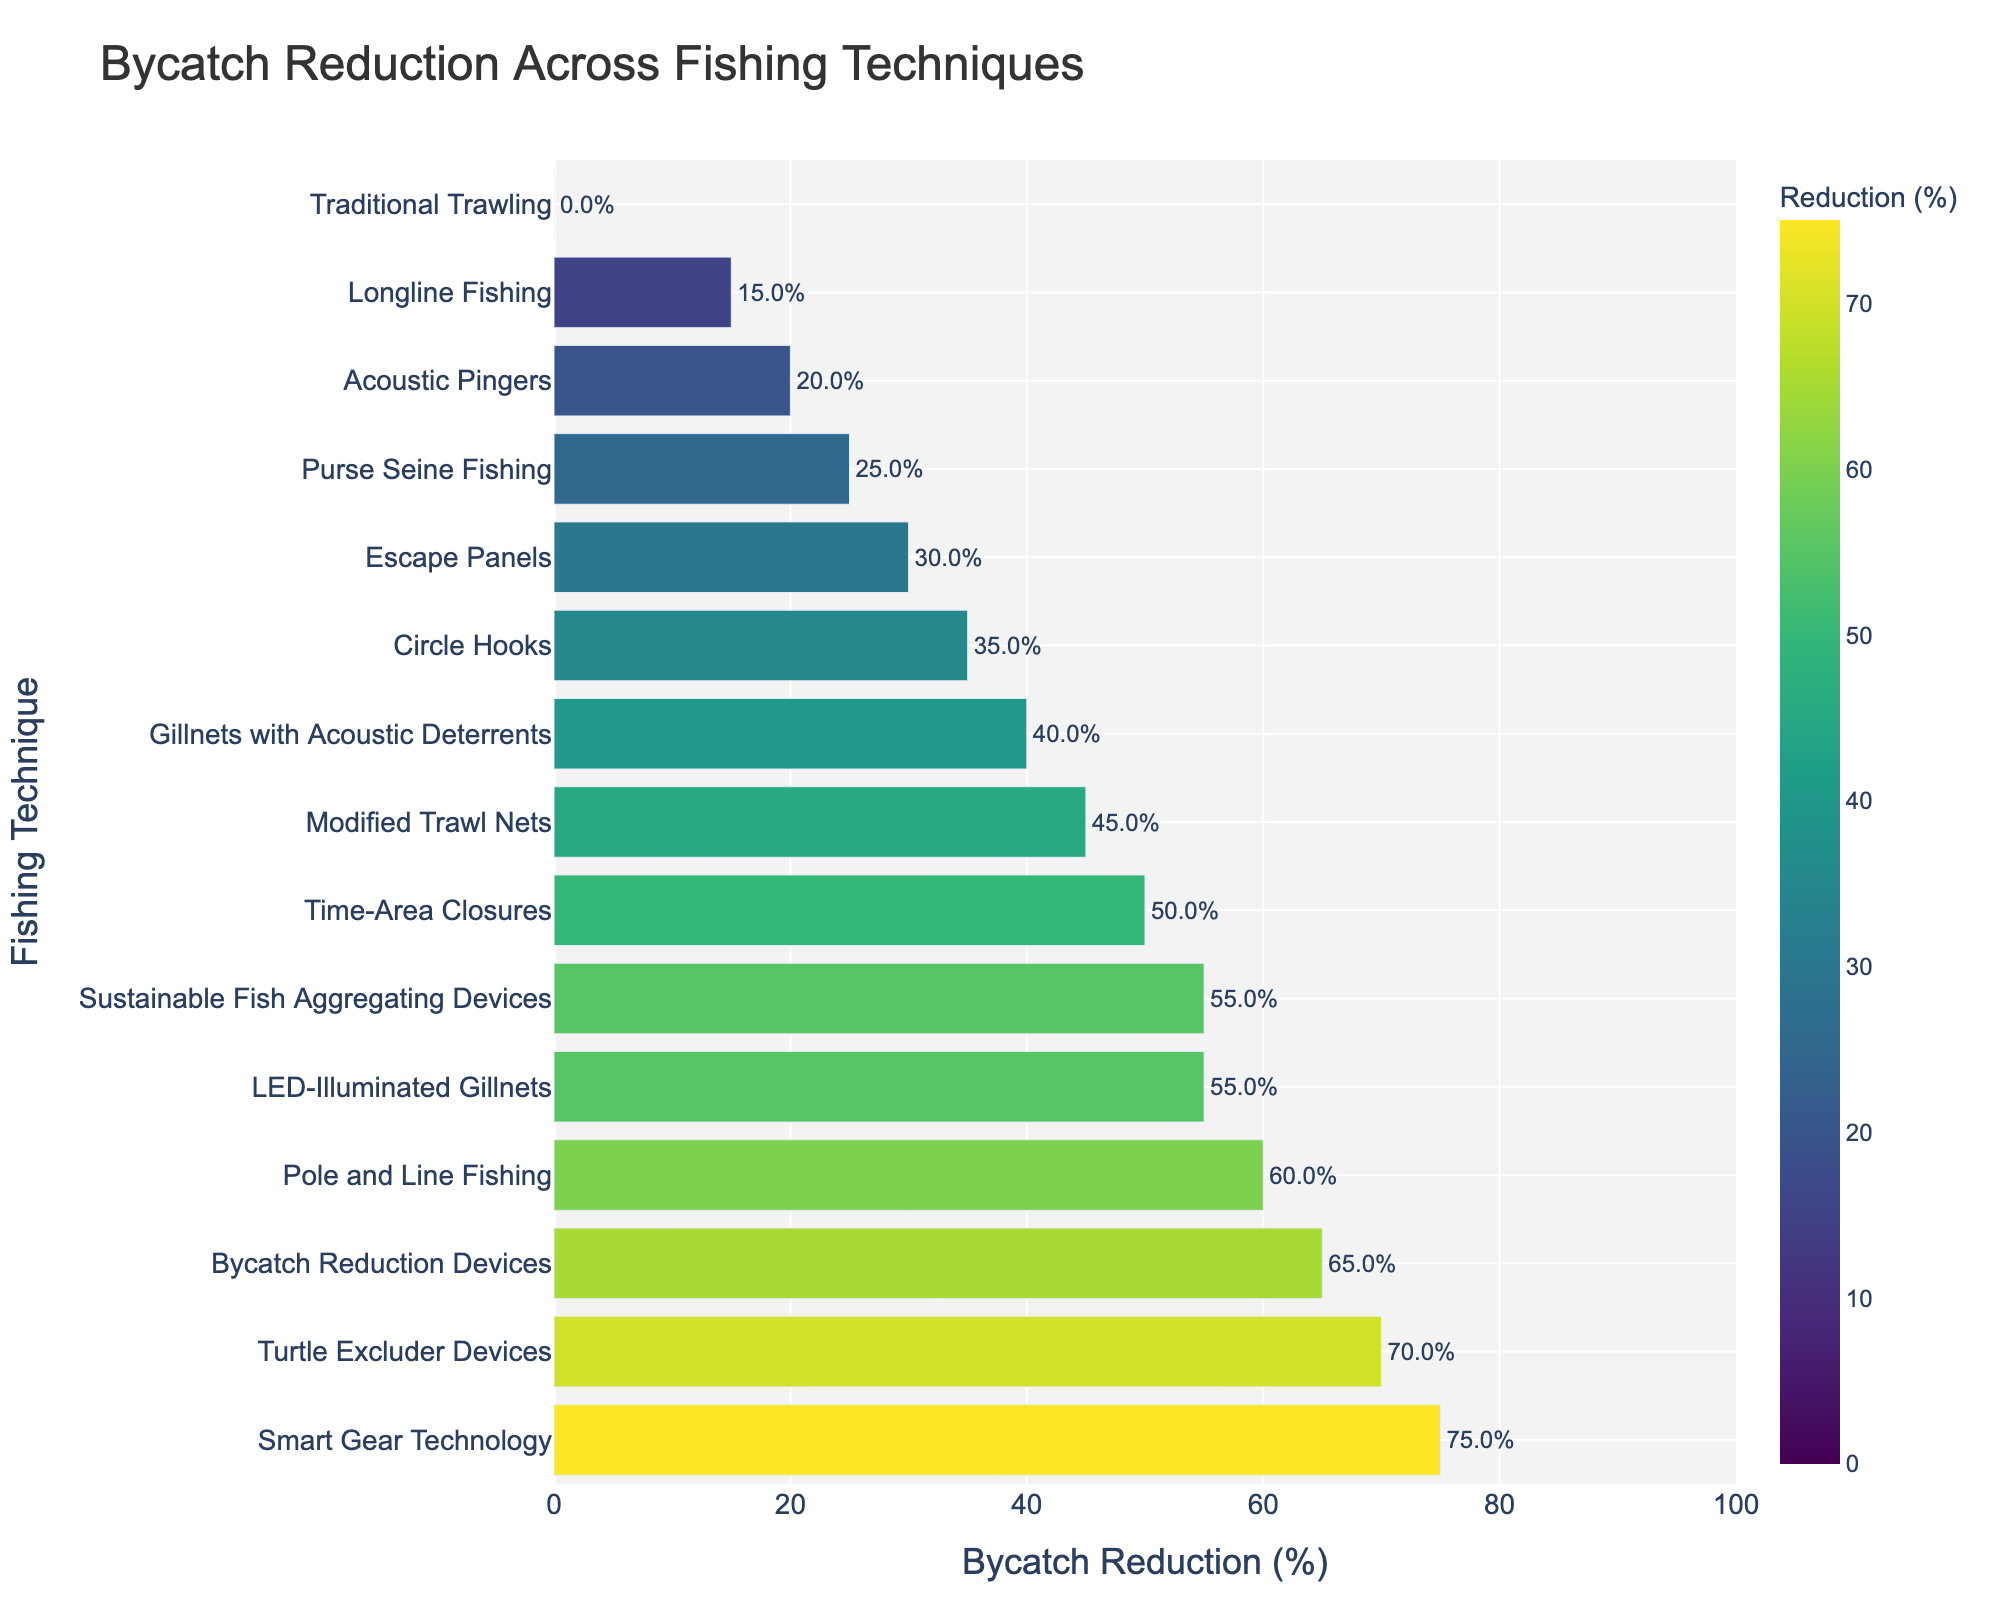What fishing technique has the highest bycatch reduction percentage? The fishing technique with the highest bycatch reduction percentage is the one that has the longest bar extending farthest to the right on the chart. In this case, it is Smart Gear Technology.
Answer: Smart Gear Technology Which technique shows a 70% reduction in bycatch? To find the technique with a 70% reduction, look for the bar whose endpoint is labeled 70%. It is the Turtle Excluder Devices.
Answer: Turtle Excluder Devices How does the bycatch reduction of Modified Trawl Nets compare to Circle Hooks? Locate the bars for both Modified Trawl Nets and Circle Hooks. Modified Trawl Nets reduce bycatch by 45%, while Circle Hooks reduce it by 35%. The difference is 10%.
Answer: Modified Trawl Nets reduce by 10% more than Circle Hooks What is the average bycatch reduction percentage among the top three techniques? Identify the top three techniques with the highest bycatch reduction percentages: Smart Gear Technology (75%), Turtle Excluder Devices (70%), and Bycatch Reduction Devices (65%). The average is (75 + 70 + 65) / 3 = 70%.
Answer: 70% Which technique has a 25% reduction, and how many techniques have a higher reduction rate? The technique with a 25% reduction is Purse Seine Fishing. Count the bars to the right of the bar for Purse Seine Fishing; there are 11 techniques with a higher reduction rate.
Answer: Purse Seine Fishing and 11 techniques Is the reduction percentage by LED-Illuminated Gillnets higher than that by Circle Hooks? Find the bars for LED-Illuminated Gillnets and Circle Hooks. LED-Illuminated Gillnets have a 55% reduction, while Circle Hooks have a 35% reduction. Yes, the reduction is higher.
Answer: Yes How much greater is the bycatch reduction for Sustainable Fish Aggregating Devices compared to Traditional Trawling? Sustainable Fish Aggregating Devices have a 55% reduction, while Traditional Trawling has 0%. The difference is 55% - 0% = 55%.
Answer: 55% Which techniques have a bycatch reduction percentage between 40% and 60%, inclusive? Identify the bars whose endpoints fall between 40% and 60%. These are Gillnets with Acoustic Deterrents (40%), Circle Hooks (35% is not included), Escape Panels (30% is not included), LED-Illuminated Gillnets (55%), Time-Area Closures (50%), and Pole and Line Fishing (60%).
Answer: Gillnets with Acoustic Deterrents, LED-Illuminated Gillnets, Time-Area Closures, and Pole and Line Fishing What is the median bycatch reduction percentage for all the techniques? List all reduction percentages in order: 0, 15, 20, 25, 30, 35, 40, 45, 50, 55, 55, 60, 65, 70, 75. The middle value, or median, is the 8th value in the list, which is 45%.
Answer: 45% What is the total bycatch reduction percentage if we sum the top two techniques? The top two techniques are Smart Gear Technology (75%) and Turtle Excluder Devices (70%). The sum is 75% + 70% = 145%.
Answer: 145% 